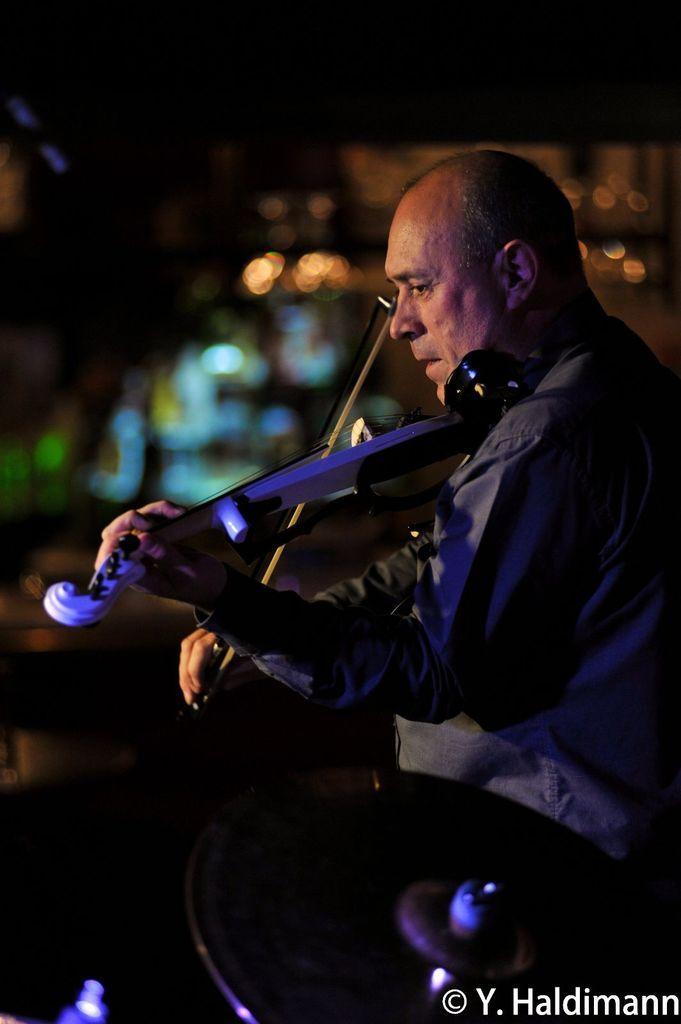Can you describe this image briefly? In this picture we can see an object and a person playing a violin and in the background we can see some objects, lights and it is blurry, in the bottom right we can see some text on it. 